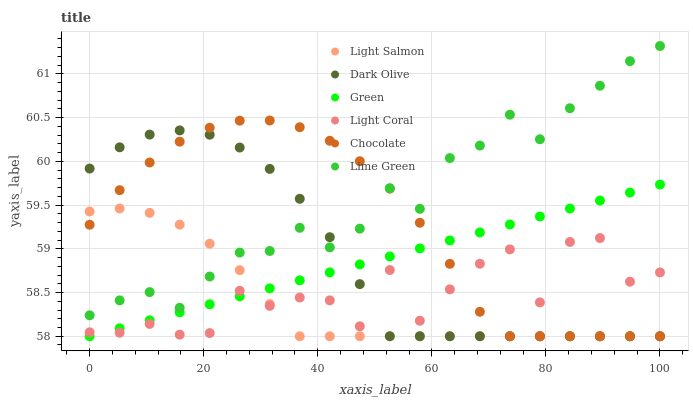Does Light Salmon have the minimum area under the curve?
Answer yes or no. Yes. Does Lime Green have the maximum area under the curve?
Answer yes or no. Yes. Does Dark Olive have the minimum area under the curve?
Answer yes or no. No. Does Dark Olive have the maximum area under the curve?
Answer yes or no. No. Is Green the smoothest?
Answer yes or no. Yes. Is Light Coral the roughest?
Answer yes or no. Yes. Is Dark Olive the smoothest?
Answer yes or no. No. Is Dark Olive the roughest?
Answer yes or no. No. Does Light Salmon have the lowest value?
Answer yes or no. Yes. Does Light Coral have the lowest value?
Answer yes or no. No. Does Lime Green have the highest value?
Answer yes or no. Yes. Does Dark Olive have the highest value?
Answer yes or no. No. Is Light Coral less than Lime Green?
Answer yes or no. Yes. Is Lime Green greater than Light Coral?
Answer yes or no. Yes. Does Light Coral intersect Light Salmon?
Answer yes or no. Yes. Is Light Coral less than Light Salmon?
Answer yes or no. No. Is Light Coral greater than Light Salmon?
Answer yes or no. No. Does Light Coral intersect Lime Green?
Answer yes or no. No. 